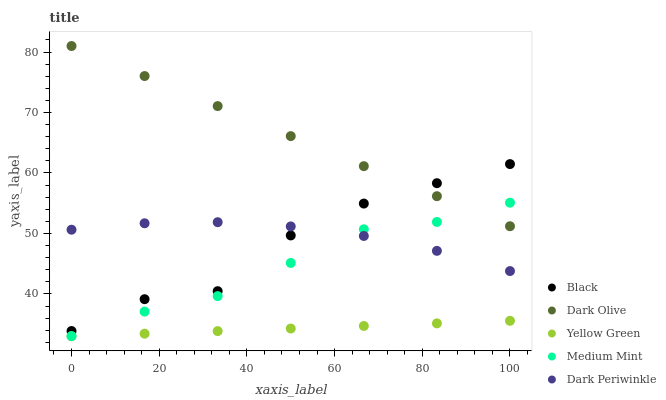Does Yellow Green have the minimum area under the curve?
Answer yes or no. Yes. Does Dark Olive have the maximum area under the curve?
Answer yes or no. Yes. Does Black have the minimum area under the curve?
Answer yes or no. No. Does Black have the maximum area under the curve?
Answer yes or no. No. Is Dark Olive the smoothest?
Answer yes or no. Yes. Is Black the roughest?
Answer yes or no. Yes. Is Black the smoothest?
Answer yes or no. No. Is Dark Olive the roughest?
Answer yes or no. No. Does Yellow Green have the lowest value?
Answer yes or no. Yes. Does Black have the lowest value?
Answer yes or no. No. Does Dark Olive have the highest value?
Answer yes or no. Yes. Does Black have the highest value?
Answer yes or no. No. Is Yellow Green less than Dark Periwinkle?
Answer yes or no. Yes. Is Dark Periwinkle greater than Yellow Green?
Answer yes or no. Yes. Does Medium Mint intersect Dark Periwinkle?
Answer yes or no. Yes. Is Medium Mint less than Dark Periwinkle?
Answer yes or no. No. Is Medium Mint greater than Dark Periwinkle?
Answer yes or no. No. Does Yellow Green intersect Dark Periwinkle?
Answer yes or no. No. 